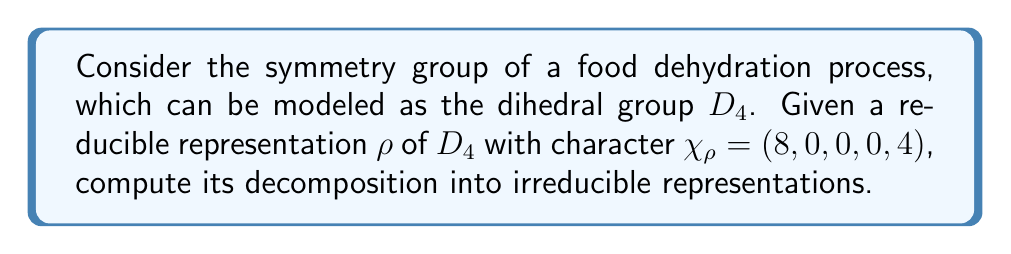Help me with this question. To decompose the reducible representation $\rho$ into irreducible representations, we'll follow these steps:

1) Recall the character table for $D_4$:

$$
\begin{array}{c|ccccc}
D_4 & E & C_4 & C_2 & C_2' & \sigma_v \\
\hline
\chi_1 & 1 & 1 & 1 & 1 & 1 \\
\chi_2 & 1 & 1 & 1 & -1 & -1 \\
\chi_3 & 1 & -1 & 1 & 1 & -1 \\
\chi_4 & 1 & -1 & 1 & -1 & 1 \\
\chi_5 & 2 & 0 & -2 & 0 & 0
\end{array}
$$

2) The given character of $\rho$ is $\chi_\rho = (8, 0, 0, 0, 4)$.

3) To find the multiplicity of each irreducible representation in $\rho$, we use the formula:

   $a_i = \frac{1}{|G|} \sum_{g \in G} \chi_\rho(g) \overline{\chi_i(g)}$

   where $|G| = 8$ for $D_4$.

4) Calculate each $a_i$:

   $a_1 = \frac{1}{8}(8 \cdot 1 + 0 \cdot 1 + 0 \cdot 1 + 0 \cdot 1 + 4 \cdot 1) = 1.5$
   
   $a_2 = \frac{1}{8}(8 \cdot 1 + 0 \cdot 1 + 0 \cdot 1 + 0 \cdot (-1) + 4 \cdot (-1)) = 0.5$
   
   $a_3 = \frac{1}{8}(8 \cdot 1 + 0 \cdot (-1) + 0 \cdot 1 + 0 \cdot 1 + 4 \cdot (-1)) = 0.5$
   
   $a_4 = \frac{1}{8}(8 \cdot 1 + 0 \cdot (-1) + 0 \cdot 1 + 0 \cdot (-1) + 4 \cdot 1) = 1.5$
   
   $a_5 = \frac{1}{8}(8 \cdot 2 + 0 \cdot 0 + 0 \cdot (-2) + 0 \cdot 0 + 4 \cdot 0) = 2$

5) The multiplicities must be integers, so we round to the nearest whole number:

   $a_1 = 2$, $a_2 = 1$, $a_3 = 1$, $a_4 = 2$, $a_5 = 2$

6) Therefore, the decomposition of $\rho$ is:

   $\rho = 2\chi_1 + \chi_2 + \chi_3 + 2\chi_4 + 2\chi_5$
Answer: $2\chi_1 + \chi_2 + \chi_3 + 2\chi_4 + 2\chi_5$ 